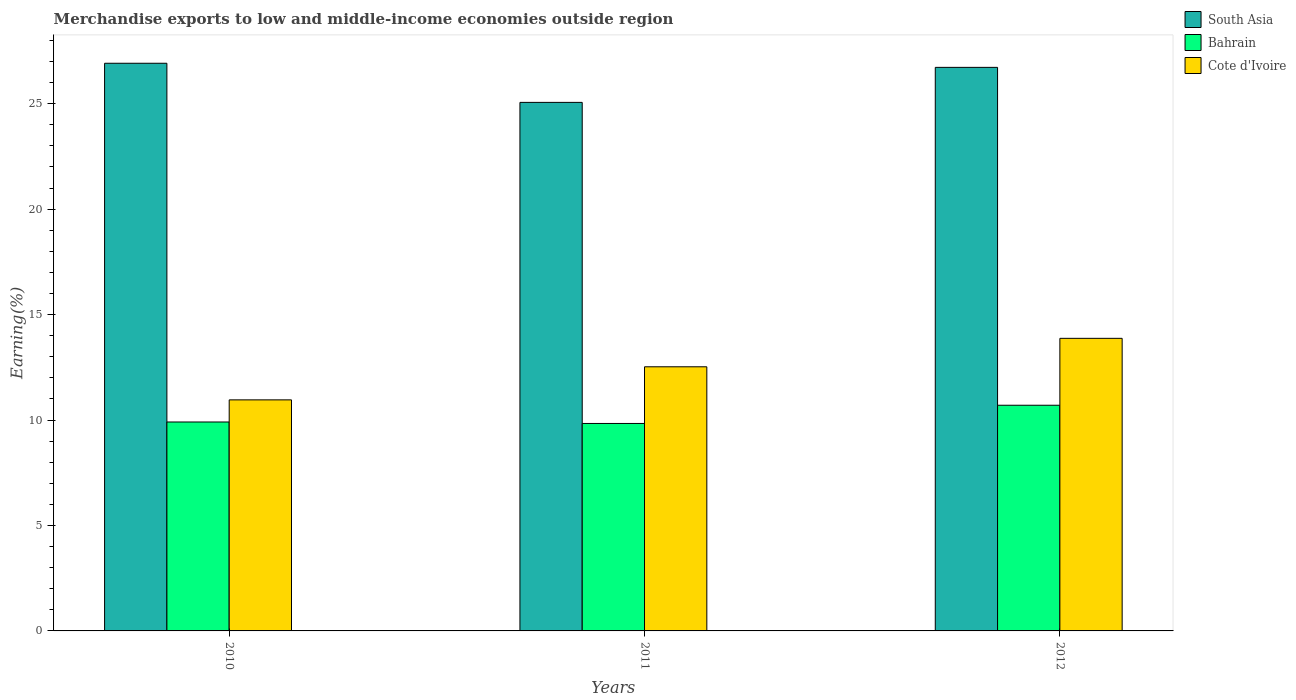How many groups of bars are there?
Make the answer very short. 3. Are the number of bars on each tick of the X-axis equal?
Your answer should be very brief. Yes. What is the percentage of amount earned from merchandise exports in Bahrain in 2011?
Your answer should be very brief. 9.84. Across all years, what is the maximum percentage of amount earned from merchandise exports in Cote d'Ivoire?
Keep it short and to the point. 13.87. Across all years, what is the minimum percentage of amount earned from merchandise exports in Bahrain?
Make the answer very short. 9.84. In which year was the percentage of amount earned from merchandise exports in South Asia maximum?
Provide a succinct answer. 2010. In which year was the percentage of amount earned from merchandise exports in Cote d'Ivoire minimum?
Your answer should be very brief. 2010. What is the total percentage of amount earned from merchandise exports in Cote d'Ivoire in the graph?
Offer a very short reply. 37.35. What is the difference between the percentage of amount earned from merchandise exports in Cote d'Ivoire in 2010 and that in 2012?
Your answer should be compact. -2.92. What is the difference between the percentage of amount earned from merchandise exports in Cote d'Ivoire in 2011 and the percentage of amount earned from merchandise exports in South Asia in 2012?
Keep it short and to the point. -14.2. What is the average percentage of amount earned from merchandise exports in South Asia per year?
Your answer should be very brief. 26.23. In the year 2010, what is the difference between the percentage of amount earned from merchandise exports in Cote d'Ivoire and percentage of amount earned from merchandise exports in South Asia?
Offer a terse response. -15.96. What is the ratio of the percentage of amount earned from merchandise exports in South Asia in 2010 to that in 2011?
Offer a very short reply. 1.07. Is the percentage of amount earned from merchandise exports in Cote d'Ivoire in 2011 less than that in 2012?
Your response must be concise. Yes. Is the difference between the percentage of amount earned from merchandise exports in Cote d'Ivoire in 2010 and 2012 greater than the difference between the percentage of amount earned from merchandise exports in South Asia in 2010 and 2012?
Your answer should be very brief. No. What is the difference between the highest and the second highest percentage of amount earned from merchandise exports in Cote d'Ivoire?
Your response must be concise. 1.35. What is the difference between the highest and the lowest percentage of amount earned from merchandise exports in Bahrain?
Keep it short and to the point. 0.86. In how many years, is the percentage of amount earned from merchandise exports in Cote d'Ivoire greater than the average percentage of amount earned from merchandise exports in Cote d'Ivoire taken over all years?
Provide a succinct answer. 2. What does the 2nd bar from the left in 2012 represents?
Your answer should be very brief. Bahrain. What does the 2nd bar from the right in 2010 represents?
Your answer should be very brief. Bahrain. Is it the case that in every year, the sum of the percentage of amount earned from merchandise exports in Bahrain and percentage of amount earned from merchandise exports in South Asia is greater than the percentage of amount earned from merchandise exports in Cote d'Ivoire?
Offer a very short reply. Yes. What is the difference between two consecutive major ticks on the Y-axis?
Your answer should be compact. 5. Are the values on the major ticks of Y-axis written in scientific E-notation?
Provide a succinct answer. No. Does the graph contain grids?
Keep it short and to the point. No. How are the legend labels stacked?
Offer a terse response. Vertical. What is the title of the graph?
Make the answer very short. Merchandise exports to low and middle-income economies outside region. What is the label or title of the X-axis?
Your answer should be very brief. Years. What is the label or title of the Y-axis?
Your answer should be compact. Earning(%). What is the Earning(%) in South Asia in 2010?
Offer a very short reply. 26.92. What is the Earning(%) in Bahrain in 2010?
Ensure brevity in your answer.  9.91. What is the Earning(%) in Cote d'Ivoire in 2010?
Your answer should be compact. 10.96. What is the Earning(%) of South Asia in 2011?
Ensure brevity in your answer.  25.06. What is the Earning(%) of Bahrain in 2011?
Provide a succinct answer. 9.84. What is the Earning(%) in Cote d'Ivoire in 2011?
Offer a very short reply. 12.52. What is the Earning(%) in South Asia in 2012?
Offer a very short reply. 26.72. What is the Earning(%) of Bahrain in 2012?
Give a very brief answer. 10.7. What is the Earning(%) of Cote d'Ivoire in 2012?
Your answer should be very brief. 13.87. Across all years, what is the maximum Earning(%) in South Asia?
Ensure brevity in your answer.  26.92. Across all years, what is the maximum Earning(%) in Bahrain?
Make the answer very short. 10.7. Across all years, what is the maximum Earning(%) of Cote d'Ivoire?
Provide a succinct answer. 13.87. Across all years, what is the minimum Earning(%) in South Asia?
Your answer should be very brief. 25.06. Across all years, what is the minimum Earning(%) in Bahrain?
Offer a terse response. 9.84. Across all years, what is the minimum Earning(%) of Cote d'Ivoire?
Your answer should be compact. 10.96. What is the total Earning(%) of South Asia in the graph?
Offer a terse response. 78.7. What is the total Earning(%) of Bahrain in the graph?
Your answer should be compact. 30.44. What is the total Earning(%) of Cote d'Ivoire in the graph?
Ensure brevity in your answer.  37.35. What is the difference between the Earning(%) in South Asia in 2010 and that in 2011?
Ensure brevity in your answer.  1.86. What is the difference between the Earning(%) in Bahrain in 2010 and that in 2011?
Your answer should be very brief. 0.07. What is the difference between the Earning(%) of Cote d'Ivoire in 2010 and that in 2011?
Your answer should be very brief. -1.57. What is the difference between the Earning(%) in South Asia in 2010 and that in 2012?
Your answer should be compact. 0.19. What is the difference between the Earning(%) of Bahrain in 2010 and that in 2012?
Offer a terse response. -0.79. What is the difference between the Earning(%) in Cote d'Ivoire in 2010 and that in 2012?
Your response must be concise. -2.92. What is the difference between the Earning(%) in South Asia in 2011 and that in 2012?
Your response must be concise. -1.66. What is the difference between the Earning(%) of Bahrain in 2011 and that in 2012?
Your answer should be compact. -0.86. What is the difference between the Earning(%) of Cote d'Ivoire in 2011 and that in 2012?
Your answer should be compact. -1.35. What is the difference between the Earning(%) of South Asia in 2010 and the Earning(%) of Bahrain in 2011?
Provide a short and direct response. 17.08. What is the difference between the Earning(%) in South Asia in 2010 and the Earning(%) in Cote d'Ivoire in 2011?
Provide a short and direct response. 14.39. What is the difference between the Earning(%) of Bahrain in 2010 and the Earning(%) of Cote d'Ivoire in 2011?
Your response must be concise. -2.62. What is the difference between the Earning(%) of South Asia in 2010 and the Earning(%) of Bahrain in 2012?
Ensure brevity in your answer.  16.21. What is the difference between the Earning(%) of South Asia in 2010 and the Earning(%) of Cote d'Ivoire in 2012?
Your answer should be very brief. 13.04. What is the difference between the Earning(%) of Bahrain in 2010 and the Earning(%) of Cote d'Ivoire in 2012?
Ensure brevity in your answer.  -3.97. What is the difference between the Earning(%) in South Asia in 2011 and the Earning(%) in Bahrain in 2012?
Your answer should be very brief. 14.36. What is the difference between the Earning(%) in South Asia in 2011 and the Earning(%) in Cote d'Ivoire in 2012?
Your response must be concise. 11.19. What is the difference between the Earning(%) in Bahrain in 2011 and the Earning(%) in Cote d'Ivoire in 2012?
Your answer should be very brief. -4.04. What is the average Earning(%) of South Asia per year?
Your response must be concise. 26.23. What is the average Earning(%) in Bahrain per year?
Give a very brief answer. 10.15. What is the average Earning(%) of Cote d'Ivoire per year?
Give a very brief answer. 12.45. In the year 2010, what is the difference between the Earning(%) in South Asia and Earning(%) in Bahrain?
Provide a succinct answer. 17.01. In the year 2010, what is the difference between the Earning(%) in South Asia and Earning(%) in Cote d'Ivoire?
Ensure brevity in your answer.  15.96. In the year 2010, what is the difference between the Earning(%) in Bahrain and Earning(%) in Cote d'Ivoire?
Provide a succinct answer. -1.05. In the year 2011, what is the difference between the Earning(%) in South Asia and Earning(%) in Bahrain?
Make the answer very short. 15.22. In the year 2011, what is the difference between the Earning(%) in South Asia and Earning(%) in Cote d'Ivoire?
Keep it short and to the point. 12.54. In the year 2011, what is the difference between the Earning(%) of Bahrain and Earning(%) of Cote d'Ivoire?
Offer a terse response. -2.69. In the year 2012, what is the difference between the Earning(%) of South Asia and Earning(%) of Bahrain?
Give a very brief answer. 16.02. In the year 2012, what is the difference between the Earning(%) in South Asia and Earning(%) in Cote d'Ivoire?
Your answer should be very brief. 12.85. In the year 2012, what is the difference between the Earning(%) of Bahrain and Earning(%) of Cote d'Ivoire?
Your answer should be compact. -3.17. What is the ratio of the Earning(%) of South Asia in 2010 to that in 2011?
Your answer should be very brief. 1.07. What is the ratio of the Earning(%) of Bahrain in 2010 to that in 2011?
Provide a short and direct response. 1.01. What is the ratio of the Earning(%) of Cote d'Ivoire in 2010 to that in 2011?
Your answer should be compact. 0.87. What is the ratio of the Earning(%) in South Asia in 2010 to that in 2012?
Your response must be concise. 1.01. What is the ratio of the Earning(%) in Bahrain in 2010 to that in 2012?
Give a very brief answer. 0.93. What is the ratio of the Earning(%) in Cote d'Ivoire in 2010 to that in 2012?
Your answer should be very brief. 0.79. What is the ratio of the Earning(%) in South Asia in 2011 to that in 2012?
Your answer should be very brief. 0.94. What is the ratio of the Earning(%) in Bahrain in 2011 to that in 2012?
Give a very brief answer. 0.92. What is the ratio of the Earning(%) in Cote d'Ivoire in 2011 to that in 2012?
Offer a terse response. 0.9. What is the difference between the highest and the second highest Earning(%) in South Asia?
Give a very brief answer. 0.19. What is the difference between the highest and the second highest Earning(%) of Bahrain?
Give a very brief answer. 0.79. What is the difference between the highest and the second highest Earning(%) of Cote d'Ivoire?
Your answer should be very brief. 1.35. What is the difference between the highest and the lowest Earning(%) in South Asia?
Provide a succinct answer. 1.86. What is the difference between the highest and the lowest Earning(%) in Bahrain?
Ensure brevity in your answer.  0.86. What is the difference between the highest and the lowest Earning(%) of Cote d'Ivoire?
Keep it short and to the point. 2.92. 